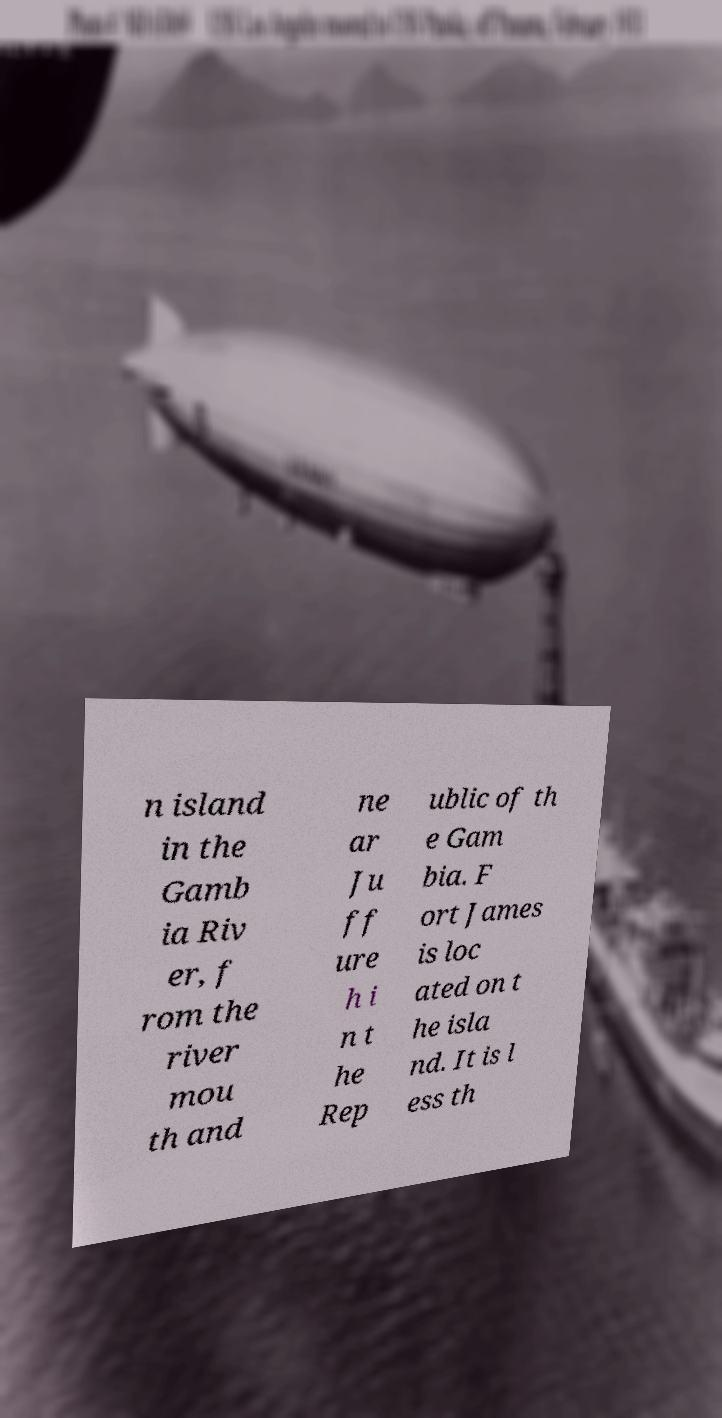Can you accurately transcribe the text from the provided image for me? n island in the Gamb ia Riv er, f rom the river mou th and ne ar Ju ff ure h i n t he Rep ublic of th e Gam bia. F ort James is loc ated on t he isla nd. It is l ess th 